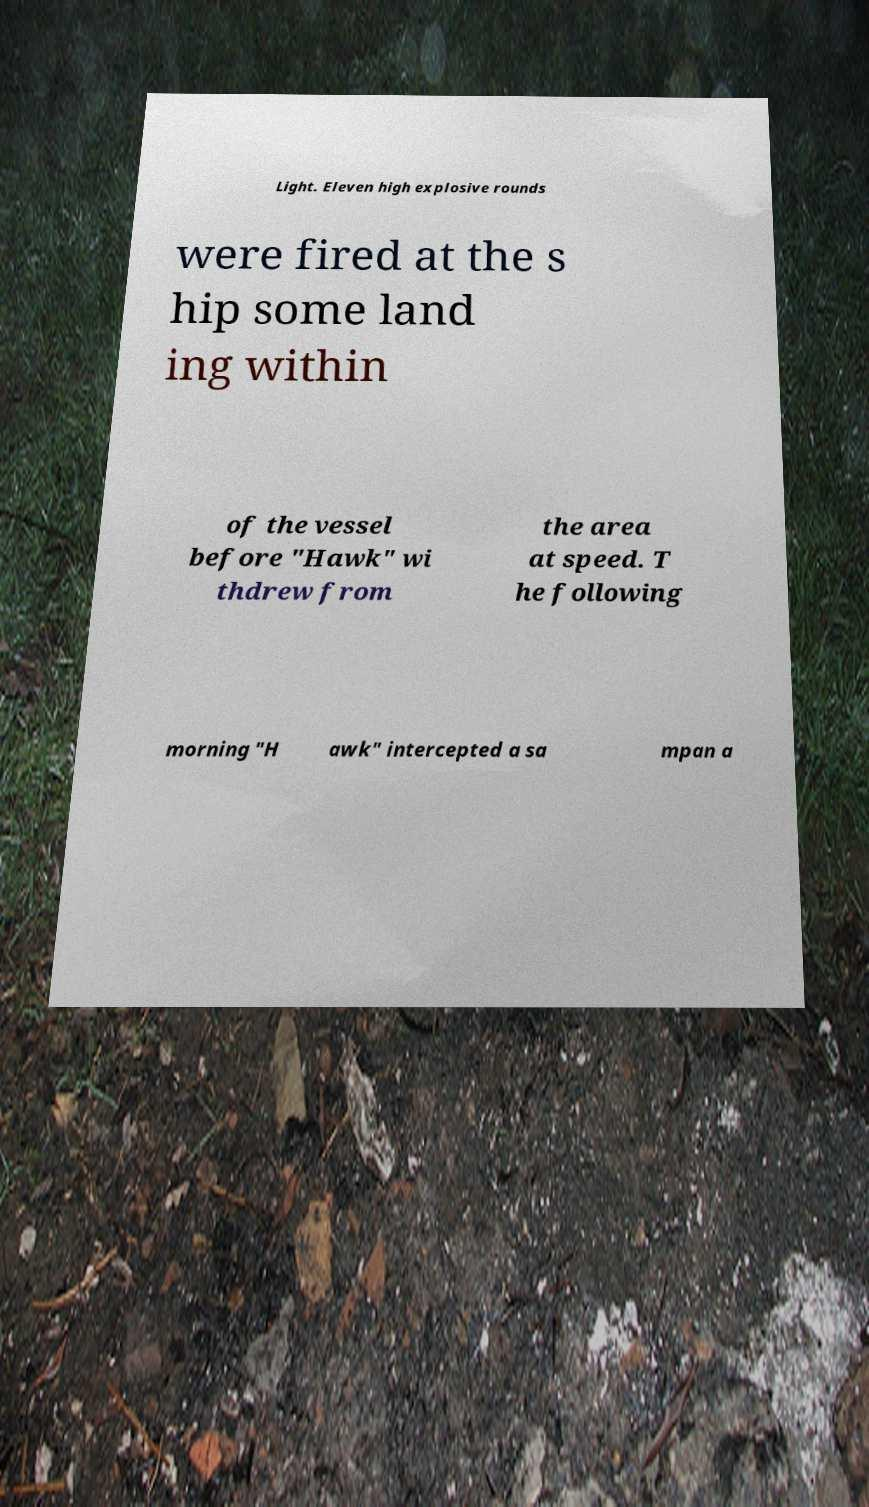Can you accurately transcribe the text from the provided image for me? Light. Eleven high explosive rounds were fired at the s hip some land ing within of the vessel before "Hawk" wi thdrew from the area at speed. T he following morning "H awk" intercepted a sa mpan a 